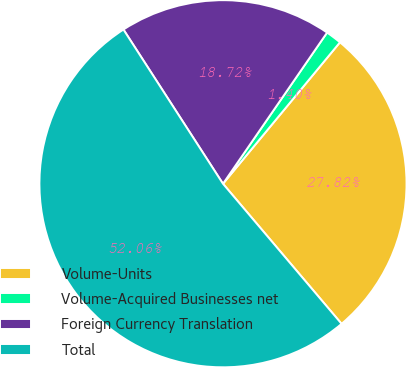Convert chart. <chart><loc_0><loc_0><loc_500><loc_500><pie_chart><fcel>Volume-Units<fcel>Volume-Acquired Businesses net<fcel>Foreign Currency Translation<fcel>Total<nl><fcel>27.82%<fcel>1.4%<fcel>18.72%<fcel>52.06%<nl></chart> 